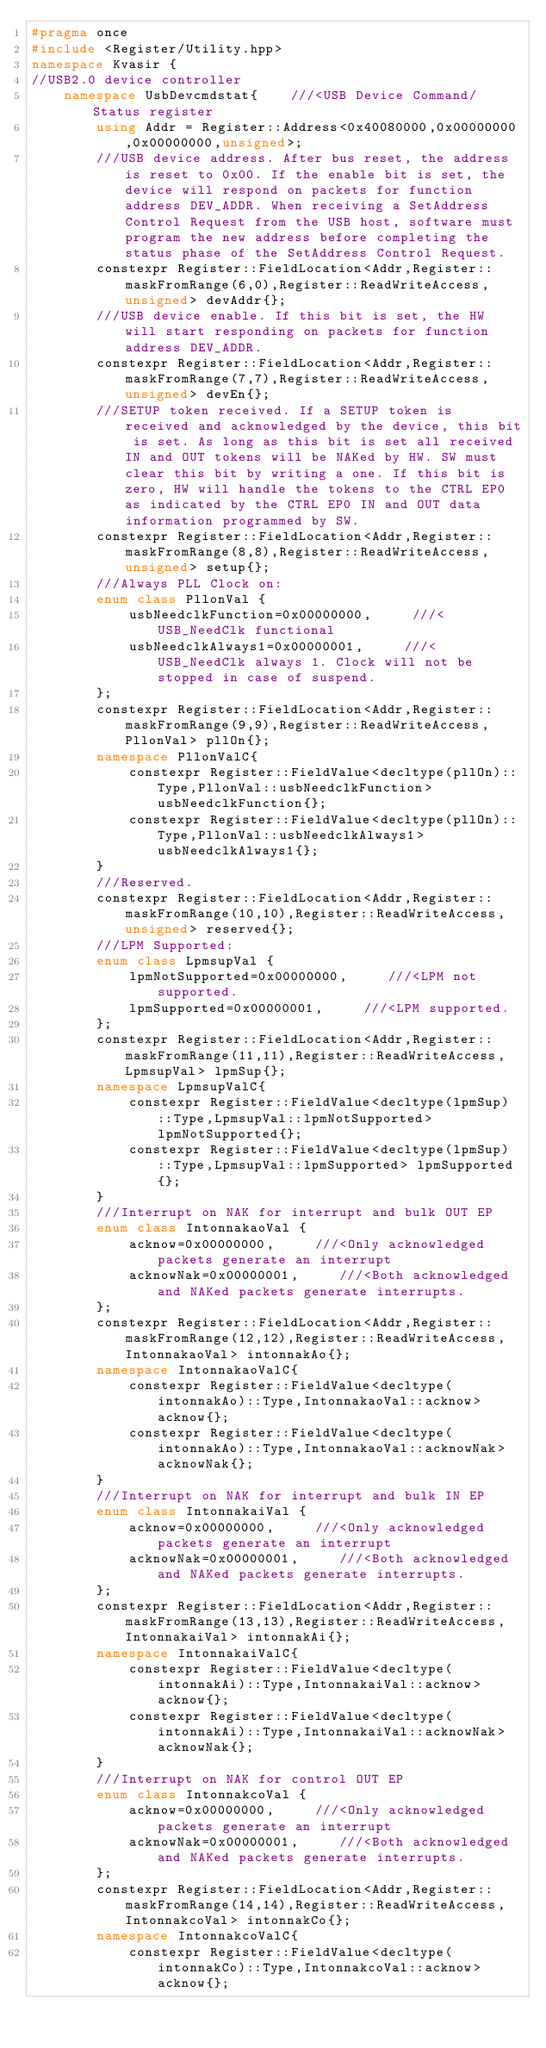Convert code to text. <code><loc_0><loc_0><loc_500><loc_500><_C++_>#pragma once 
#include <Register/Utility.hpp>
namespace Kvasir {
//USB2.0 device controller
    namespace UsbDevcmdstat{    ///<USB Device Command/Status register
        using Addr = Register::Address<0x40080000,0x00000000,0x00000000,unsigned>;
        ///USB device address. After bus reset, the address is reset to 0x00. If the enable bit is set, the device will respond on packets for function address DEV_ADDR. When receiving a SetAddress Control Request from the USB host, software must program the new address before completing the status phase of the SetAddress Control Request.
        constexpr Register::FieldLocation<Addr,Register::maskFromRange(6,0),Register::ReadWriteAccess,unsigned> devAddr{}; 
        ///USB device enable. If this bit is set, the HW will start responding on packets for function address DEV_ADDR.
        constexpr Register::FieldLocation<Addr,Register::maskFromRange(7,7),Register::ReadWriteAccess,unsigned> devEn{}; 
        ///SETUP token received. If a SETUP token is received and acknowledged by the device, this bit is set. As long as this bit is set all received IN and OUT tokens will be NAKed by HW. SW must clear this bit by writing a one. If this bit is zero, HW will handle the tokens to the CTRL EP0 as indicated by the CTRL EP0 IN and OUT data information programmed by SW.
        constexpr Register::FieldLocation<Addr,Register::maskFromRange(8,8),Register::ReadWriteAccess,unsigned> setup{}; 
        ///Always PLL Clock on:
        enum class PllonVal {
            usbNeedclkFunction=0x00000000,     ///<USB_NeedClk functional
            usbNeedclkAlways1=0x00000001,     ///<USB_NeedClk always 1. Clock will not be stopped in case of suspend.
        };
        constexpr Register::FieldLocation<Addr,Register::maskFromRange(9,9),Register::ReadWriteAccess,PllonVal> pllOn{}; 
        namespace PllonValC{
            constexpr Register::FieldValue<decltype(pllOn)::Type,PllonVal::usbNeedclkFunction> usbNeedclkFunction{};
            constexpr Register::FieldValue<decltype(pllOn)::Type,PllonVal::usbNeedclkAlways1> usbNeedclkAlways1{};
        }
        ///Reserved.
        constexpr Register::FieldLocation<Addr,Register::maskFromRange(10,10),Register::ReadWriteAccess,unsigned> reserved{}; 
        ///LPM Supported:
        enum class LpmsupVal {
            lpmNotSupported=0x00000000,     ///<LPM not supported.
            lpmSupported=0x00000001,     ///<LPM supported.
        };
        constexpr Register::FieldLocation<Addr,Register::maskFromRange(11,11),Register::ReadWriteAccess,LpmsupVal> lpmSup{}; 
        namespace LpmsupValC{
            constexpr Register::FieldValue<decltype(lpmSup)::Type,LpmsupVal::lpmNotSupported> lpmNotSupported{};
            constexpr Register::FieldValue<decltype(lpmSup)::Type,LpmsupVal::lpmSupported> lpmSupported{};
        }
        ///Interrupt on NAK for interrupt and bulk OUT EP
        enum class IntonnakaoVal {
            acknow=0x00000000,     ///<Only acknowledged packets generate an interrupt
            acknowNak=0x00000001,     ///<Both acknowledged and NAKed packets generate interrupts.
        };
        constexpr Register::FieldLocation<Addr,Register::maskFromRange(12,12),Register::ReadWriteAccess,IntonnakaoVal> intonnakAo{}; 
        namespace IntonnakaoValC{
            constexpr Register::FieldValue<decltype(intonnakAo)::Type,IntonnakaoVal::acknow> acknow{};
            constexpr Register::FieldValue<decltype(intonnakAo)::Type,IntonnakaoVal::acknowNak> acknowNak{};
        }
        ///Interrupt on NAK for interrupt and bulk IN EP
        enum class IntonnakaiVal {
            acknow=0x00000000,     ///<Only acknowledged packets generate an interrupt
            acknowNak=0x00000001,     ///<Both acknowledged and NAKed packets generate interrupts.
        };
        constexpr Register::FieldLocation<Addr,Register::maskFromRange(13,13),Register::ReadWriteAccess,IntonnakaiVal> intonnakAi{}; 
        namespace IntonnakaiValC{
            constexpr Register::FieldValue<decltype(intonnakAi)::Type,IntonnakaiVal::acknow> acknow{};
            constexpr Register::FieldValue<decltype(intonnakAi)::Type,IntonnakaiVal::acknowNak> acknowNak{};
        }
        ///Interrupt on NAK for control OUT EP
        enum class IntonnakcoVal {
            acknow=0x00000000,     ///<Only acknowledged packets generate an interrupt
            acknowNak=0x00000001,     ///<Both acknowledged and NAKed packets generate interrupts.
        };
        constexpr Register::FieldLocation<Addr,Register::maskFromRange(14,14),Register::ReadWriteAccess,IntonnakcoVal> intonnakCo{}; 
        namespace IntonnakcoValC{
            constexpr Register::FieldValue<decltype(intonnakCo)::Type,IntonnakcoVal::acknow> acknow{};</code> 